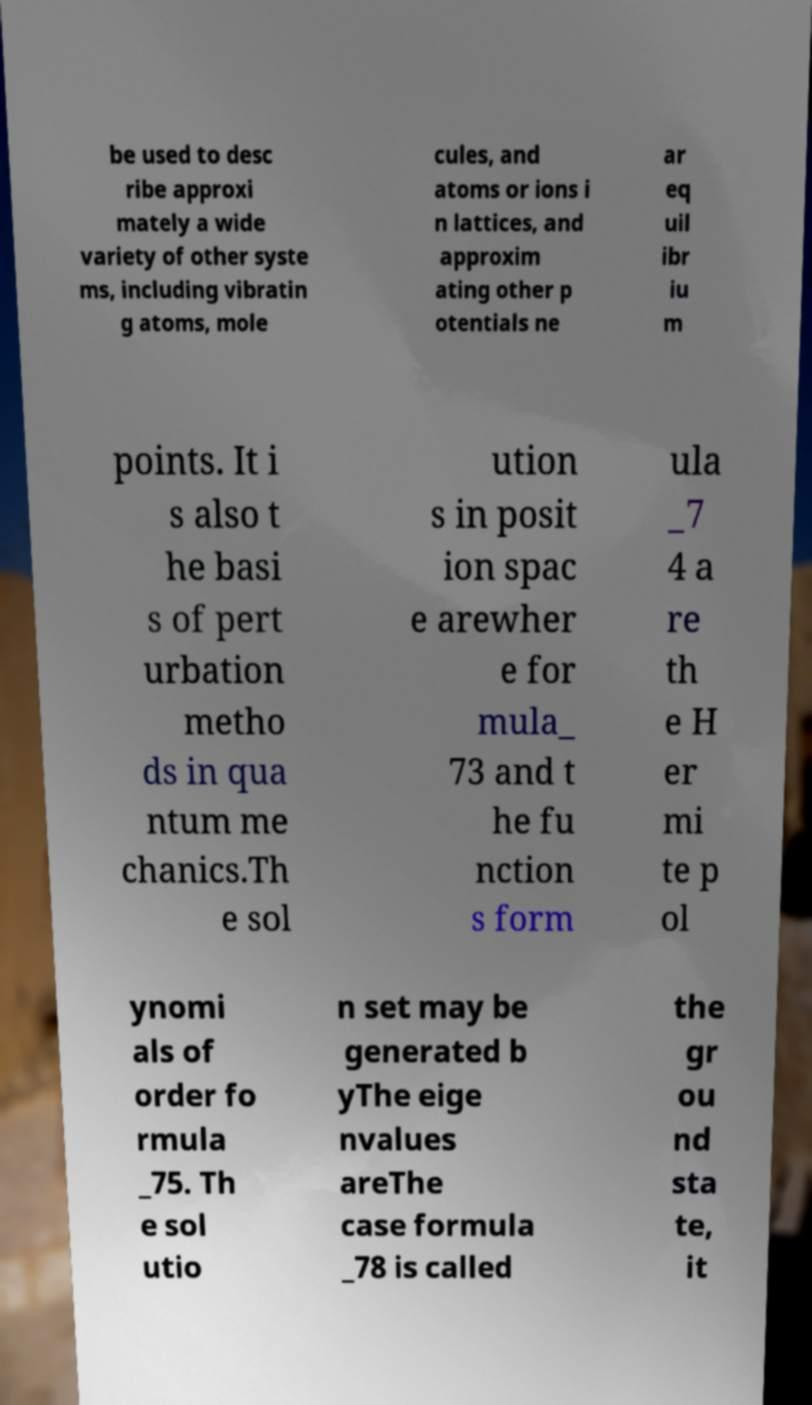Can you accurately transcribe the text from the provided image for me? be used to desc ribe approxi mately a wide variety of other syste ms, including vibratin g atoms, mole cules, and atoms or ions i n lattices, and approxim ating other p otentials ne ar eq uil ibr iu m points. It i s also t he basi s of pert urbation metho ds in qua ntum me chanics.Th e sol ution s in posit ion spac e arewher e for mula_ 73 and t he fu nction s form ula _7 4 a re th e H er mi te p ol ynomi als of order fo rmula _75. Th e sol utio n set may be generated b yThe eige nvalues areThe case formula _78 is called the gr ou nd sta te, it 